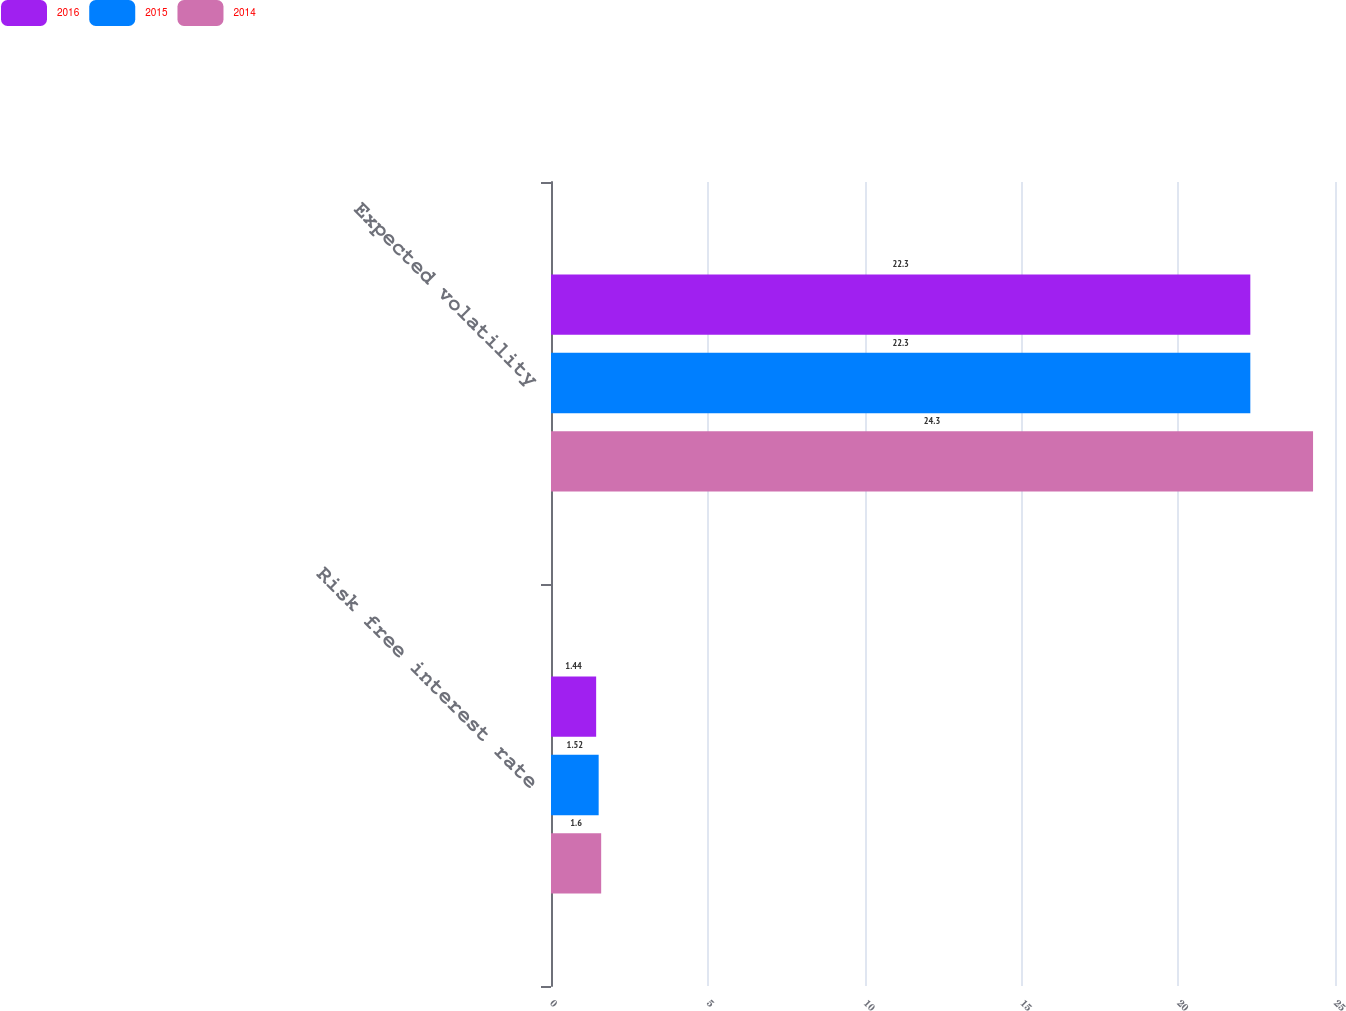Convert chart. <chart><loc_0><loc_0><loc_500><loc_500><stacked_bar_chart><ecel><fcel>Risk free interest rate<fcel>Expected volatility<nl><fcel>2016<fcel>1.44<fcel>22.3<nl><fcel>2015<fcel>1.52<fcel>22.3<nl><fcel>2014<fcel>1.6<fcel>24.3<nl></chart> 